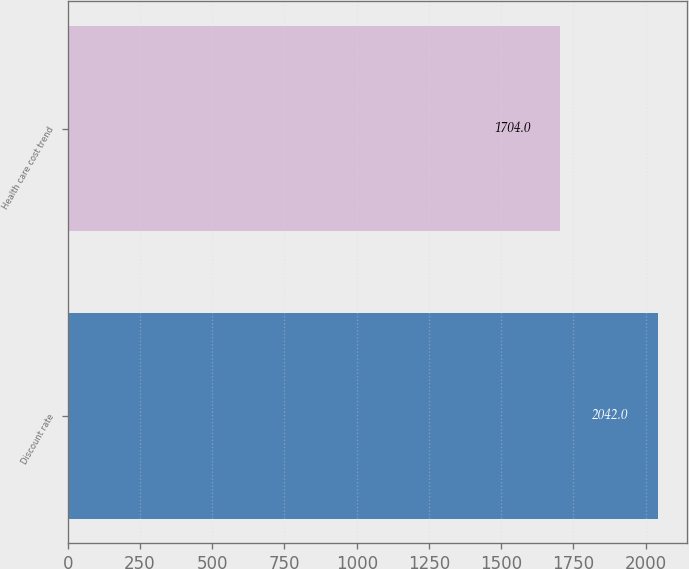Convert chart to OTSL. <chart><loc_0><loc_0><loc_500><loc_500><bar_chart><fcel>Discount rate<fcel>Health care cost trend<nl><fcel>2042<fcel>1704<nl></chart> 